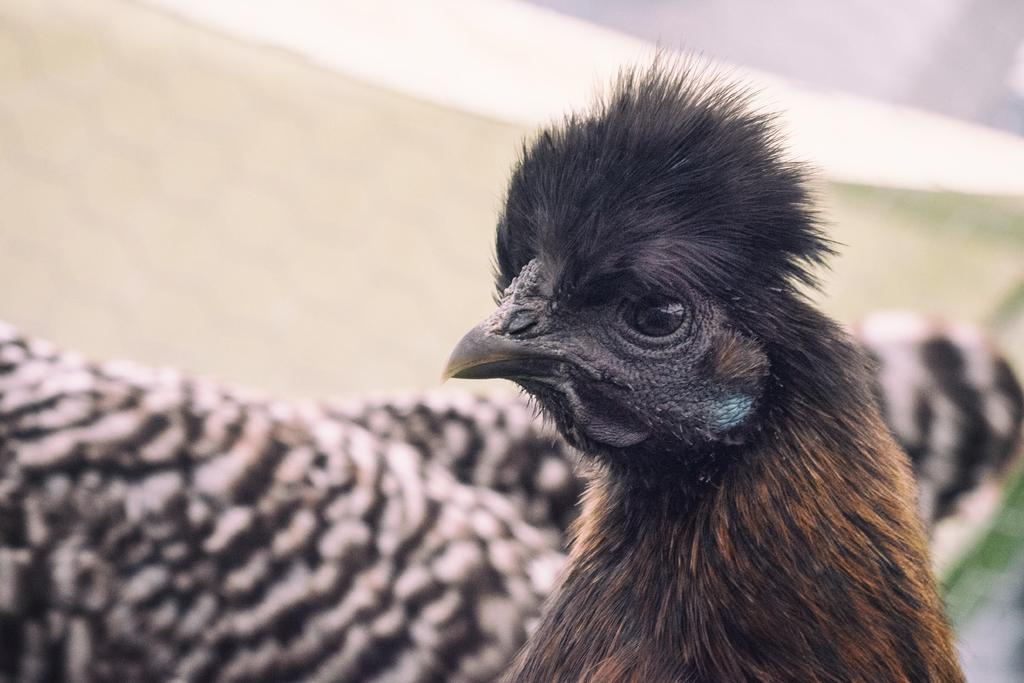What type of animal is in the image? There is a bird in the image. What colors can be seen on the bird? The bird has brown and black colors. What colors are present in the background of the image? The background of the image is white and cream colored. What type of map can be seen in the image? There is no map present in the image; it features a bird with brown and black colors against a white and cream colored background. 